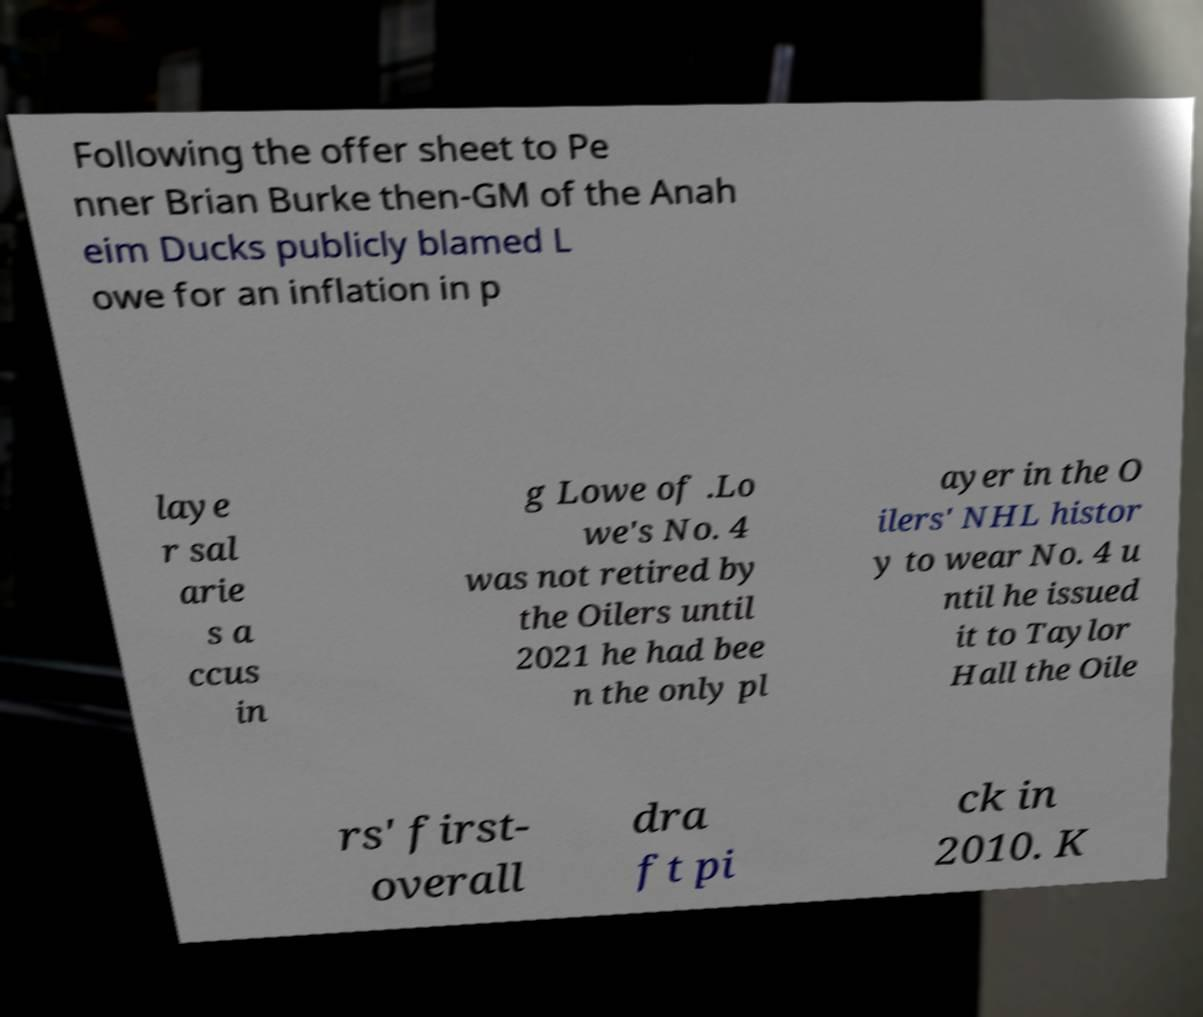What messages or text are displayed in this image? I need them in a readable, typed format. Following the offer sheet to Pe nner Brian Burke then-GM of the Anah eim Ducks publicly blamed L owe for an inflation in p laye r sal arie s a ccus in g Lowe of .Lo we's No. 4 was not retired by the Oilers until 2021 he had bee n the only pl ayer in the O ilers' NHL histor y to wear No. 4 u ntil he issued it to Taylor Hall the Oile rs' first- overall dra ft pi ck in 2010. K 